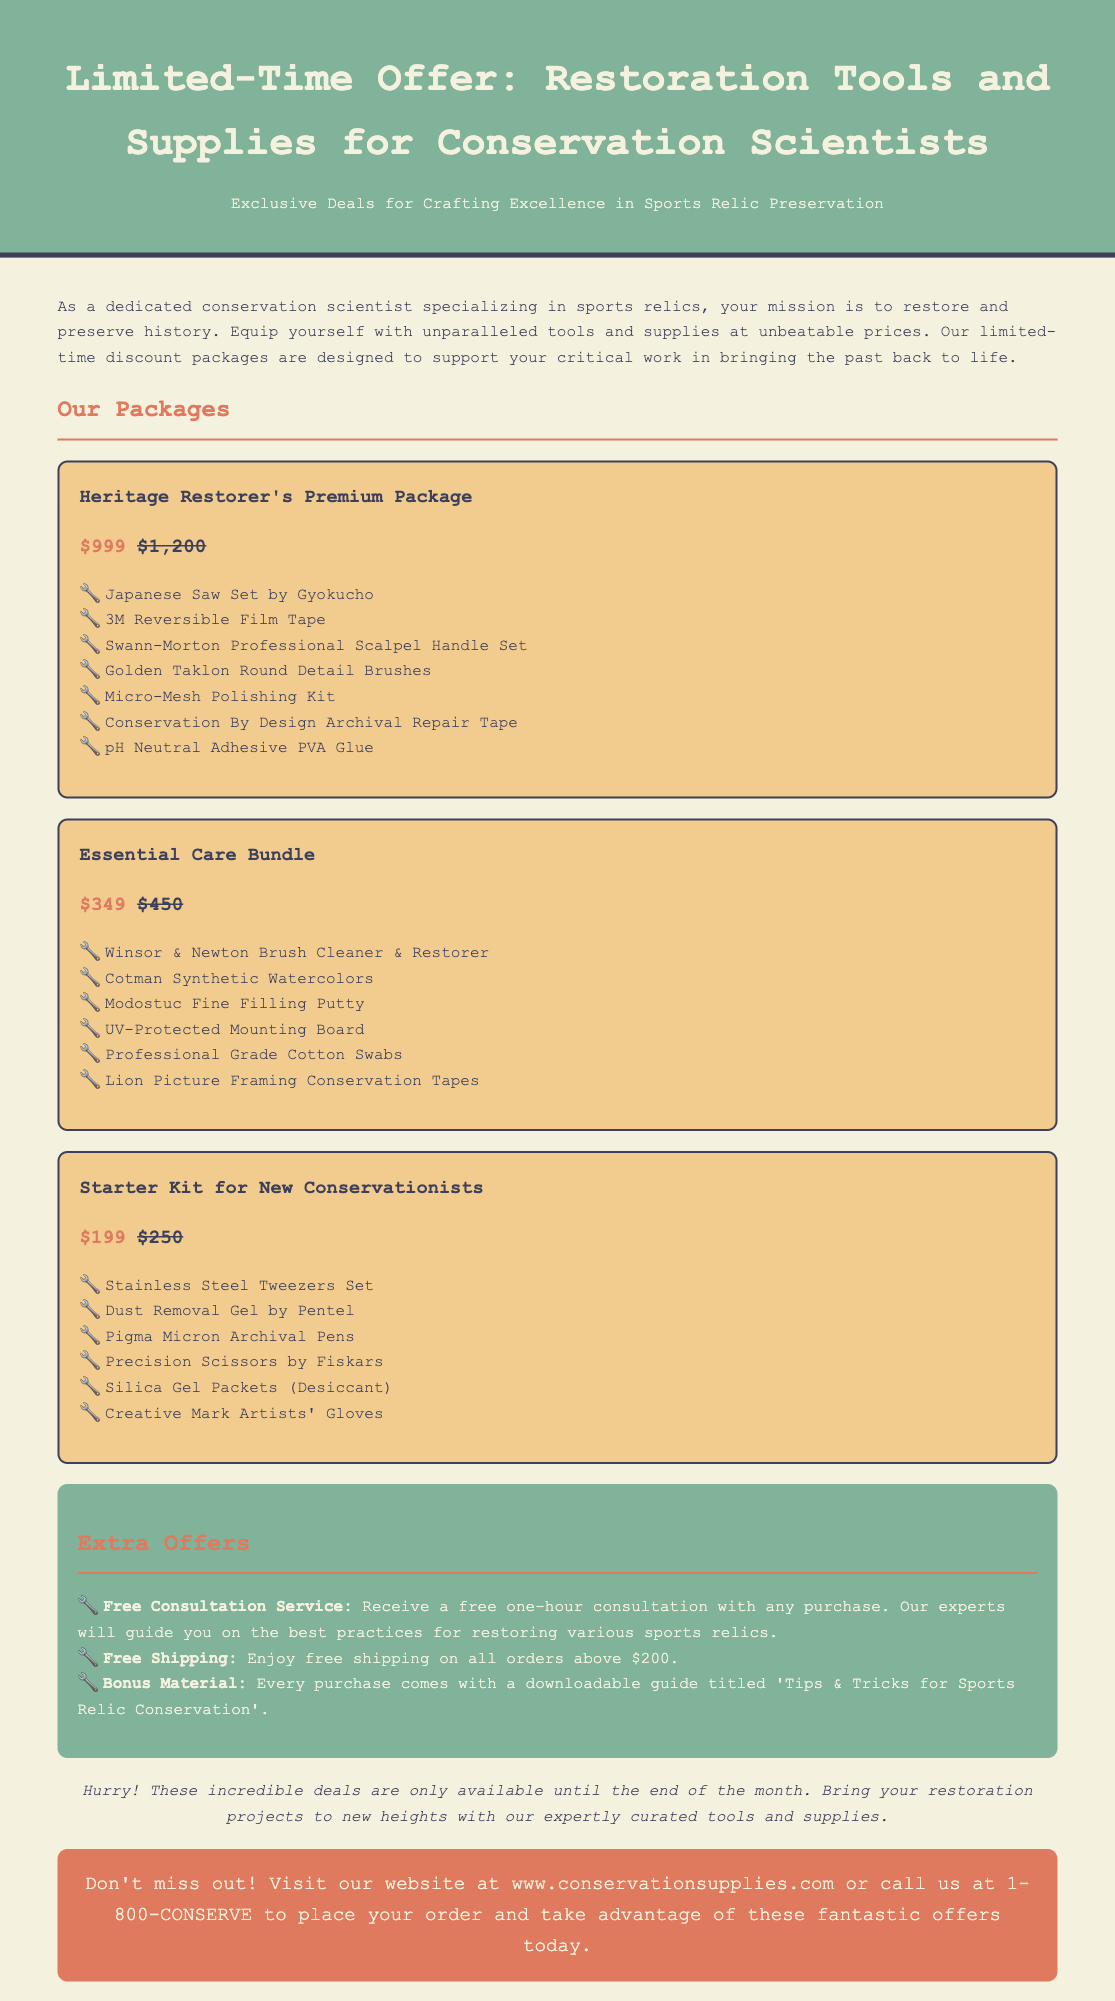What is the title of the advertisement? The title of the advertisement is prominently displayed at the top of the document, stating the main offer.
Answer: Limited-Time Offer: Restoration Tools and Supplies for Conservation Scientists What is the total discount for the Heritage Restorer's Premium Package? The Heritage Restorer's Premium Package costs $999 after a discount and originally was $1,200, so the discount is calculated as $1,200 - $999.
Answer: $201 What is the price of the Starter Kit for New Conservationists? The price for the Starter Kit for New Conservationists is listed as one of the package prices in the document.
Answer: $199 What bonus material is included with each purchase? The bonus material provided with every purchase is specified in the extra offers section of the document.
Answer: Downloadable guide titled 'Tips & Tricks for Sports Relic Conservation' How many offers are listed in the advertisement? The document includes several packages and extra offers; counting them gives us the total number.
Answer: Three offers are listed (Heritage Restorer's Premium Package, Essential Care Bundle, Starter Kit for New Conservationists) What service is offered for free with any purchase? The service given for free is mentioned clearly in the extra offers section of the advertisement.
Answer: Free Consultation Service What is the color of the background used in the advertisement? The background color for the advertisement body is described in the CSS styling of the document.
Answer: Light beige When does the limited-time offer end? The document specifies a deadline for the offer, providing urgency to potential customers.
Answer: End of the month 